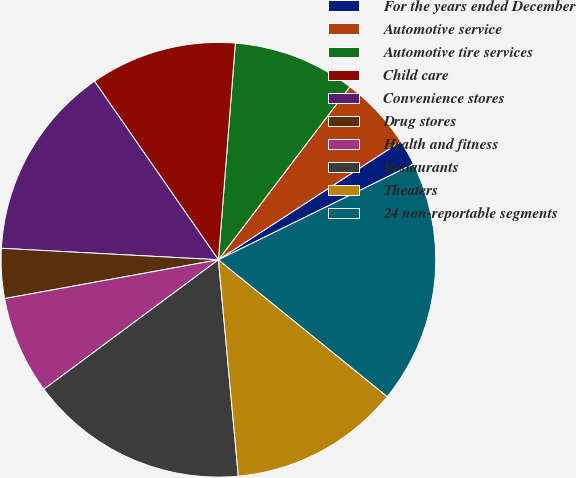Convert chart. <chart><loc_0><loc_0><loc_500><loc_500><pie_chart><fcel>For the years ended December<fcel>Automotive service<fcel>Automotive tire services<fcel>Child care<fcel>Convenience stores<fcel>Drug stores<fcel>Health and fitness<fcel>Restaurants<fcel>Theaters<fcel>24 non-reportable segments<nl><fcel>1.9%<fcel>5.5%<fcel>9.1%<fcel>10.9%<fcel>14.5%<fcel>3.7%<fcel>7.3%<fcel>16.3%<fcel>12.7%<fcel>18.1%<nl></chart> 